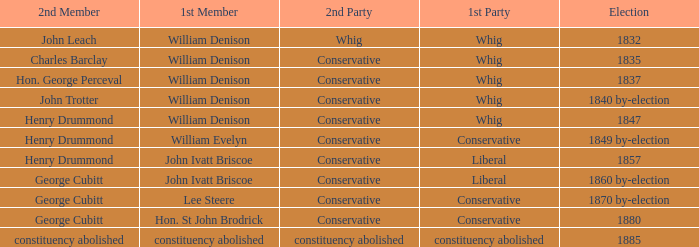Which party with an 1835 election has 1st member William Denison? Conservative. Parse the table in full. {'header': ['2nd Member', '1st Member', '2nd Party', '1st Party', 'Election'], 'rows': [['John Leach', 'William Denison', 'Whig', 'Whig', '1832'], ['Charles Barclay', 'William Denison', 'Conservative', 'Whig', '1835'], ['Hon. George Perceval', 'William Denison', 'Conservative', 'Whig', '1837'], ['John Trotter', 'William Denison', 'Conservative', 'Whig', '1840 by-election'], ['Henry Drummond', 'William Denison', 'Conservative', 'Whig', '1847'], ['Henry Drummond', 'William Evelyn', 'Conservative', 'Conservative', '1849 by-election'], ['Henry Drummond', 'John Ivatt Briscoe', 'Conservative', 'Liberal', '1857'], ['George Cubitt', 'John Ivatt Briscoe', 'Conservative', 'Liberal', '1860 by-election'], ['George Cubitt', 'Lee Steere', 'Conservative', 'Conservative', '1870 by-election'], ['George Cubitt', 'Hon. St John Brodrick', 'Conservative', 'Conservative', '1880'], ['constituency abolished', 'constituency abolished', 'constituency abolished', 'constituency abolished', '1885']]} 